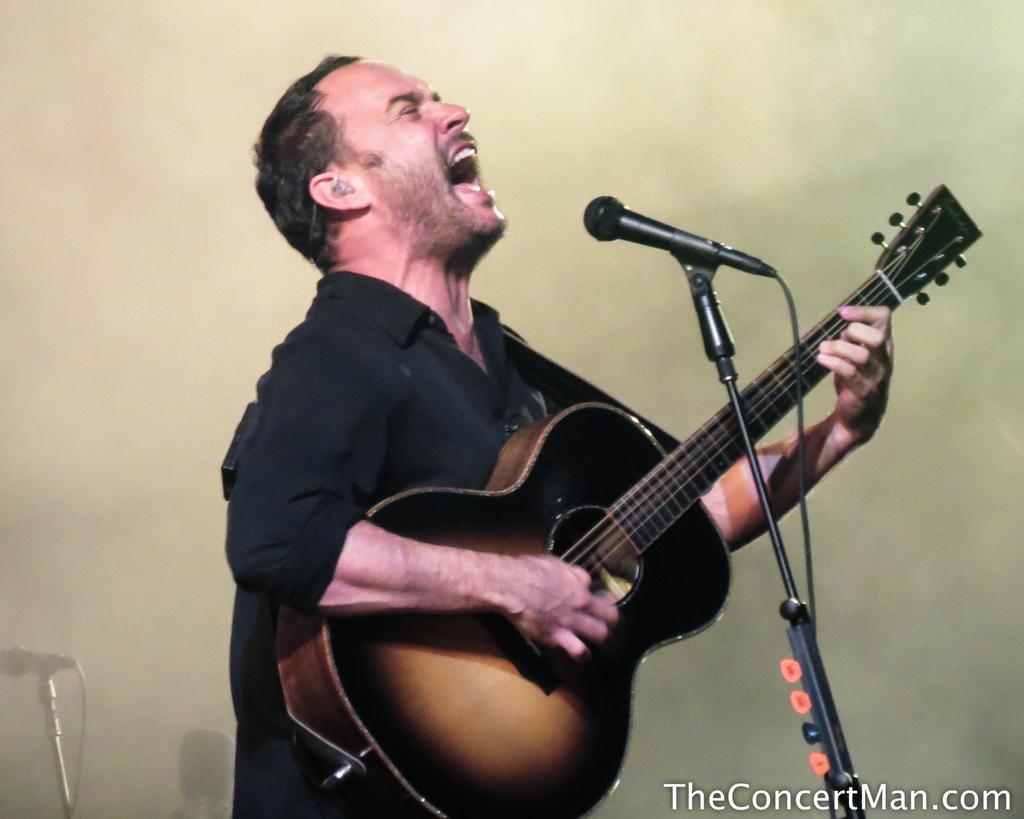What is the person in the image doing? The person is standing and holding a guitar. What is the person also doing while holding the guitar? The person is singing. What object is present in the image that is commonly used for amplifying sound? There is a microphone with a stand in the image. What type of knee injury can be seen in the image? There is no knee injury present in the image; it features a person holding a guitar and singing. How many yams are visible in the image? There are no yams present in the image. 